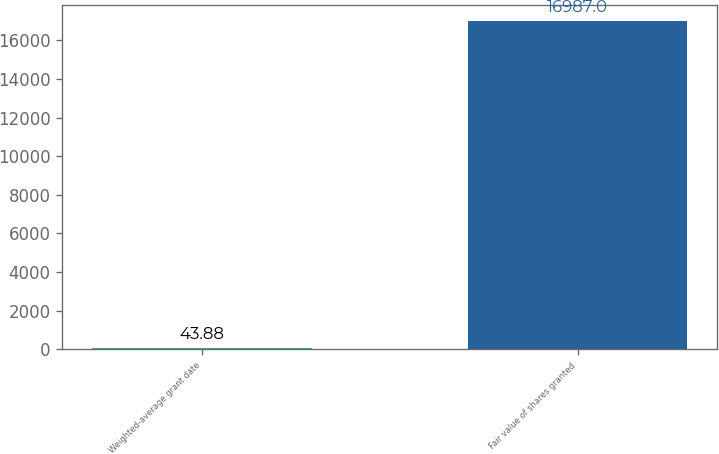Convert chart to OTSL. <chart><loc_0><loc_0><loc_500><loc_500><bar_chart><fcel>Weighted-average grant date<fcel>Fair value of shares granted<nl><fcel>43.88<fcel>16987<nl></chart> 